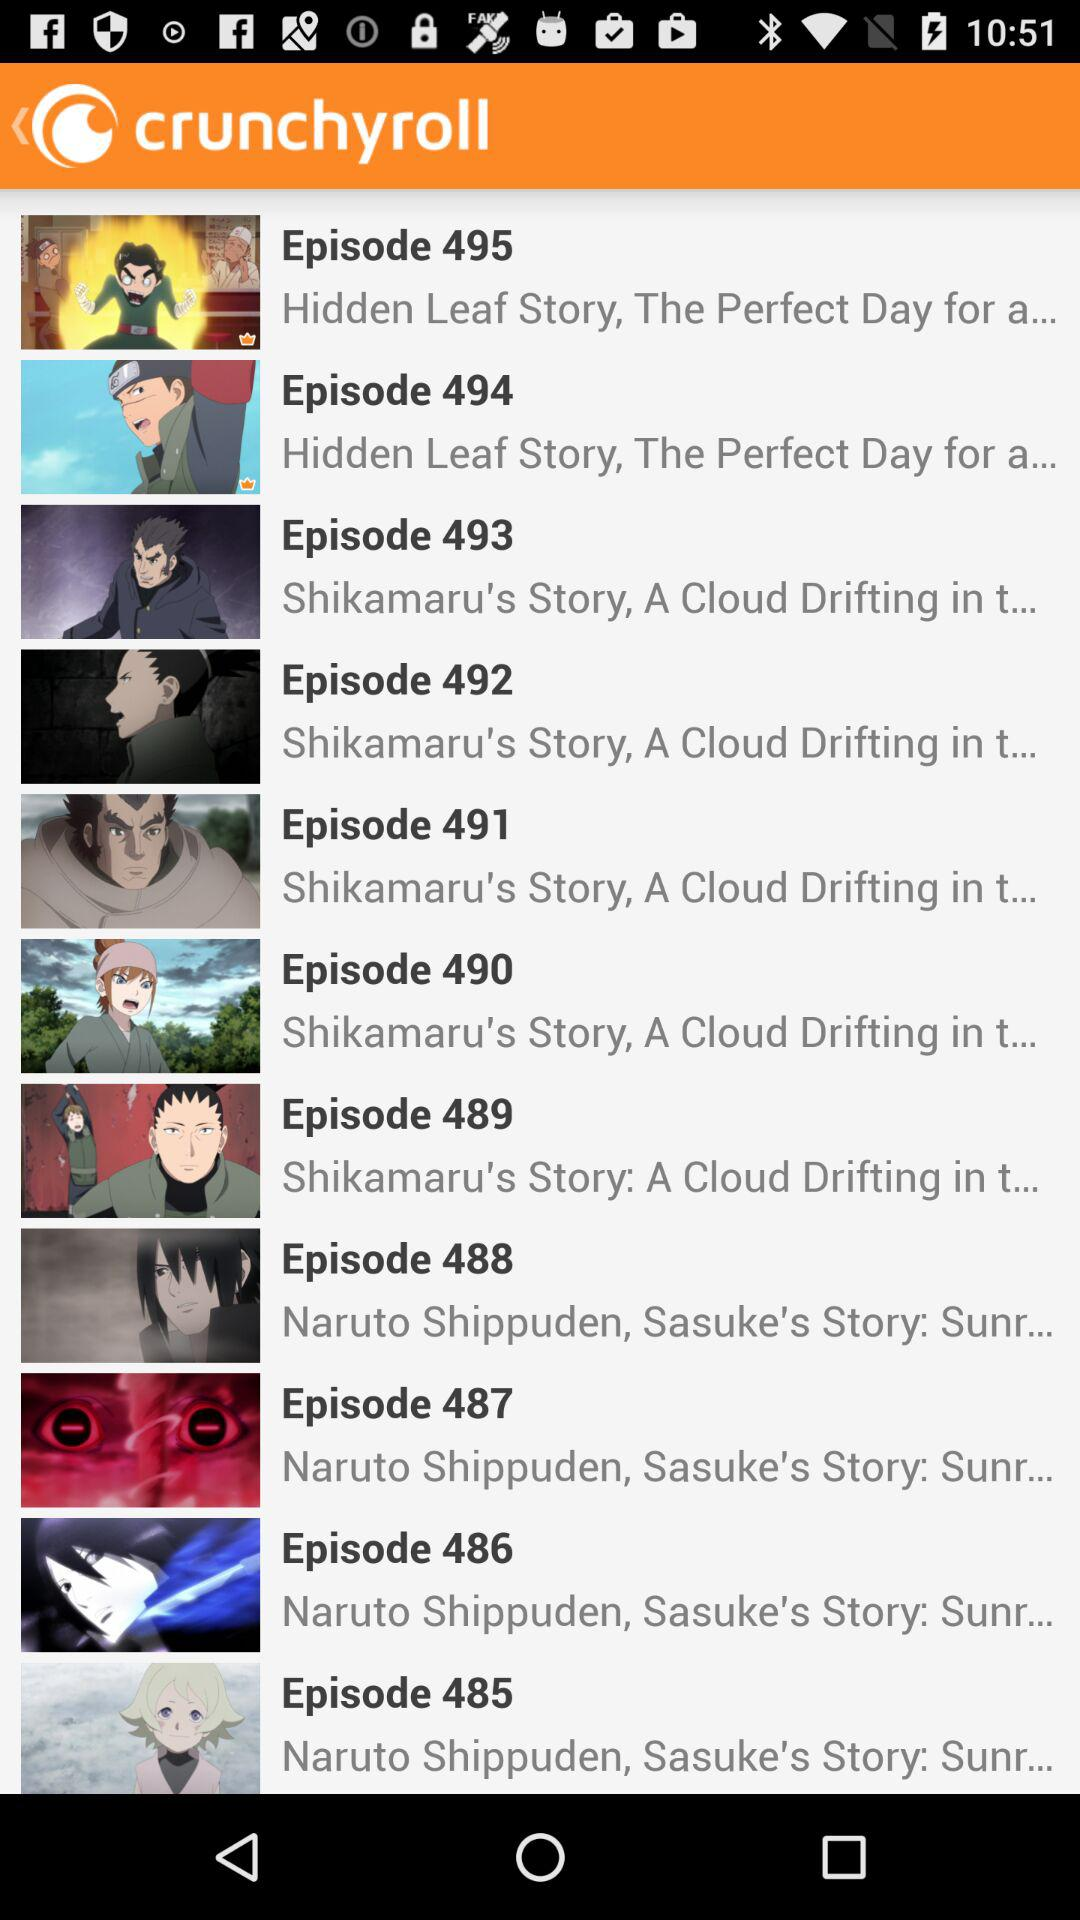What is the episode name of episode 488? The episode name is "Naruto Shippuden, Sasuke's Story: Sunr...". 